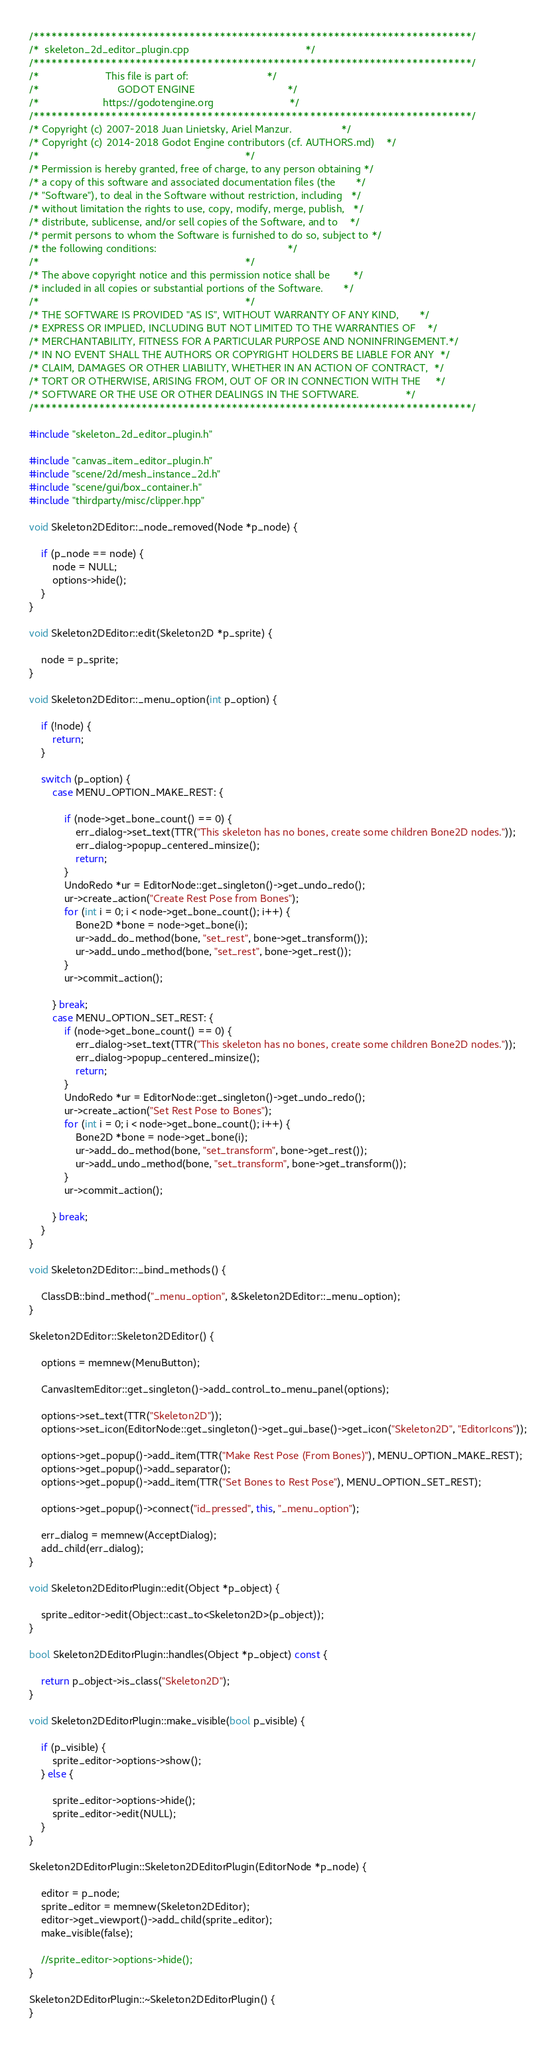<code> <loc_0><loc_0><loc_500><loc_500><_C++_>/*************************************************************************/
/*  skeleton_2d_editor_plugin.cpp                                        */
/*************************************************************************/
/*                       This file is part of:                           */
/*                           GODOT ENGINE                                */
/*                      https://godotengine.org                          */
/*************************************************************************/
/* Copyright (c) 2007-2018 Juan Linietsky, Ariel Manzur.                 */
/* Copyright (c) 2014-2018 Godot Engine contributors (cf. AUTHORS.md)    */
/*                                                                       */
/* Permission is hereby granted, free of charge, to any person obtaining */
/* a copy of this software and associated documentation files (the       */
/* "Software"), to deal in the Software without restriction, including   */
/* without limitation the rights to use, copy, modify, merge, publish,   */
/* distribute, sublicense, and/or sell copies of the Software, and to    */
/* permit persons to whom the Software is furnished to do so, subject to */
/* the following conditions:                                             */
/*                                                                       */
/* The above copyright notice and this permission notice shall be        */
/* included in all copies or substantial portions of the Software.       */
/*                                                                       */
/* THE SOFTWARE IS PROVIDED "AS IS", WITHOUT WARRANTY OF ANY KIND,       */
/* EXPRESS OR IMPLIED, INCLUDING BUT NOT LIMITED TO THE WARRANTIES OF    */
/* MERCHANTABILITY, FITNESS FOR A PARTICULAR PURPOSE AND NONINFRINGEMENT.*/
/* IN NO EVENT SHALL THE AUTHORS OR COPYRIGHT HOLDERS BE LIABLE FOR ANY  */
/* CLAIM, DAMAGES OR OTHER LIABILITY, WHETHER IN AN ACTION OF CONTRACT,  */
/* TORT OR OTHERWISE, ARISING FROM, OUT OF OR IN CONNECTION WITH THE     */
/* SOFTWARE OR THE USE OR OTHER DEALINGS IN THE SOFTWARE.                */
/*************************************************************************/

#include "skeleton_2d_editor_plugin.h"

#include "canvas_item_editor_plugin.h"
#include "scene/2d/mesh_instance_2d.h"
#include "scene/gui/box_container.h"
#include "thirdparty/misc/clipper.hpp"

void Skeleton2DEditor::_node_removed(Node *p_node) {

	if (p_node == node) {
		node = NULL;
		options->hide();
	}
}

void Skeleton2DEditor::edit(Skeleton2D *p_sprite) {

	node = p_sprite;
}

void Skeleton2DEditor::_menu_option(int p_option) {

	if (!node) {
		return;
	}

	switch (p_option) {
		case MENU_OPTION_MAKE_REST: {

			if (node->get_bone_count() == 0) {
				err_dialog->set_text(TTR("This skeleton has no bones, create some children Bone2D nodes."));
				err_dialog->popup_centered_minsize();
				return;
			}
			UndoRedo *ur = EditorNode::get_singleton()->get_undo_redo();
			ur->create_action("Create Rest Pose from Bones");
			for (int i = 0; i < node->get_bone_count(); i++) {
				Bone2D *bone = node->get_bone(i);
				ur->add_do_method(bone, "set_rest", bone->get_transform());
				ur->add_undo_method(bone, "set_rest", bone->get_rest());
			}
			ur->commit_action();

		} break;
		case MENU_OPTION_SET_REST: {
			if (node->get_bone_count() == 0) {
				err_dialog->set_text(TTR("This skeleton has no bones, create some children Bone2D nodes."));
				err_dialog->popup_centered_minsize();
				return;
			}
			UndoRedo *ur = EditorNode::get_singleton()->get_undo_redo();
			ur->create_action("Set Rest Pose to Bones");
			for (int i = 0; i < node->get_bone_count(); i++) {
				Bone2D *bone = node->get_bone(i);
				ur->add_do_method(bone, "set_transform", bone->get_rest());
				ur->add_undo_method(bone, "set_transform", bone->get_transform());
			}
			ur->commit_action();

		} break;
	}
}

void Skeleton2DEditor::_bind_methods() {

	ClassDB::bind_method("_menu_option", &Skeleton2DEditor::_menu_option);
}

Skeleton2DEditor::Skeleton2DEditor() {

	options = memnew(MenuButton);

	CanvasItemEditor::get_singleton()->add_control_to_menu_panel(options);

	options->set_text(TTR("Skeleton2D"));
	options->set_icon(EditorNode::get_singleton()->get_gui_base()->get_icon("Skeleton2D", "EditorIcons"));

	options->get_popup()->add_item(TTR("Make Rest Pose (From Bones)"), MENU_OPTION_MAKE_REST);
	options->get_popup()->add_separator();
	options->get_popup()->add_item(TTR("Set Bones to Rest Pose"), MENU_OPTION_SET_REST);

	options->get_popup()->connect("id_pressed", this, "_menu_option");

	err_dialog = memnew(AcceptDialog);
	add_child(err_dialog);
}

void Skeleton2DEditorPlugin::edit(Object *p_object) {

	sprite_editor->edit(Object::cast_to<Skeleton2D>(p_object));
}

bool Skeleton2DEditorPlugin::handles(Object *p_object) const {

	return p_object->is_class("Skeleton2D");
}

void Skeleton2DEditorPlugin::make_visible(bool p_visible) {

	if (p_visible) {
		sprite_editor->options->show();
	} else {

		sprite_editor->options->hide();
		sprite_editor->edit(NULL);
	}
}

Skeleton2DEditorPlugin::Skeleton2DEditorPlugin(EditorNode *p_node) {

	editor = p_node;
	sprite_editor = memnew(Skeleton2DEditor);
	editor->get_viewport()->add_child(sprite_editor);
	make_visible(false);

	//sprite_editor->options->hide();
}

Skeleton2DEditorPlugin::~Skeleton2DEditorPlugin() {
}
</code> 